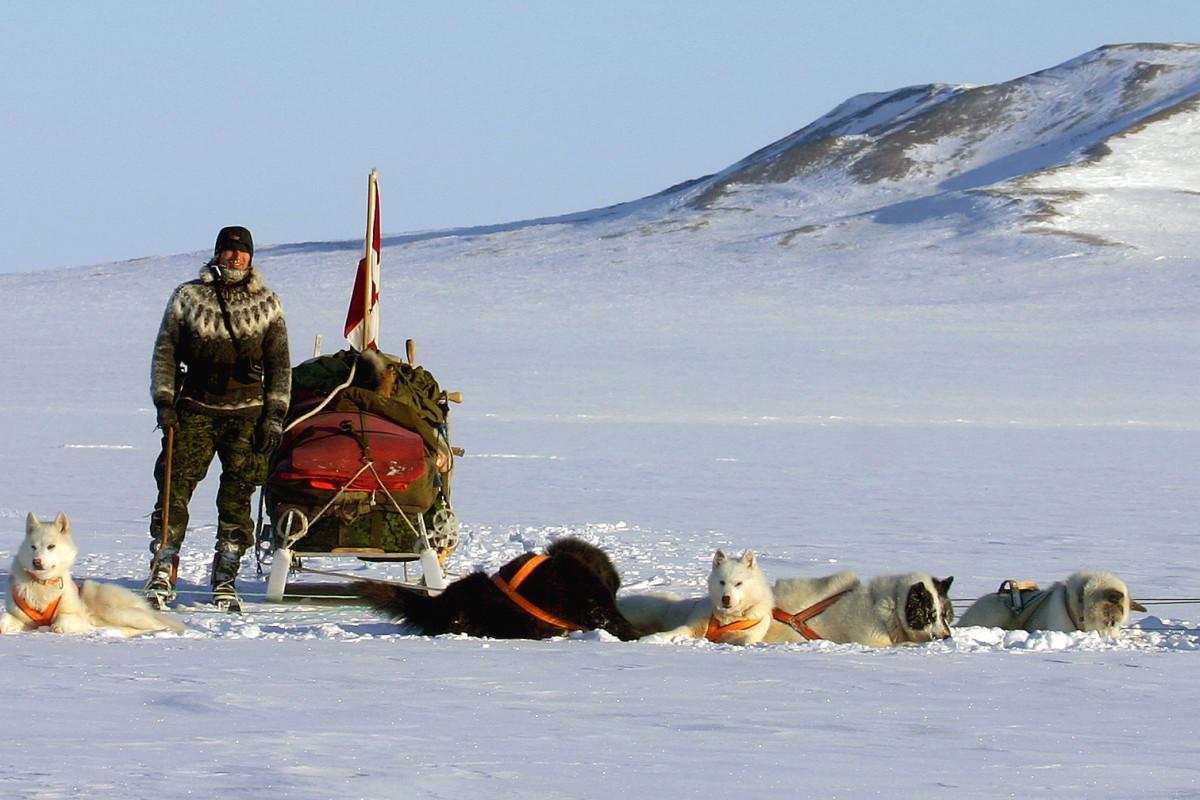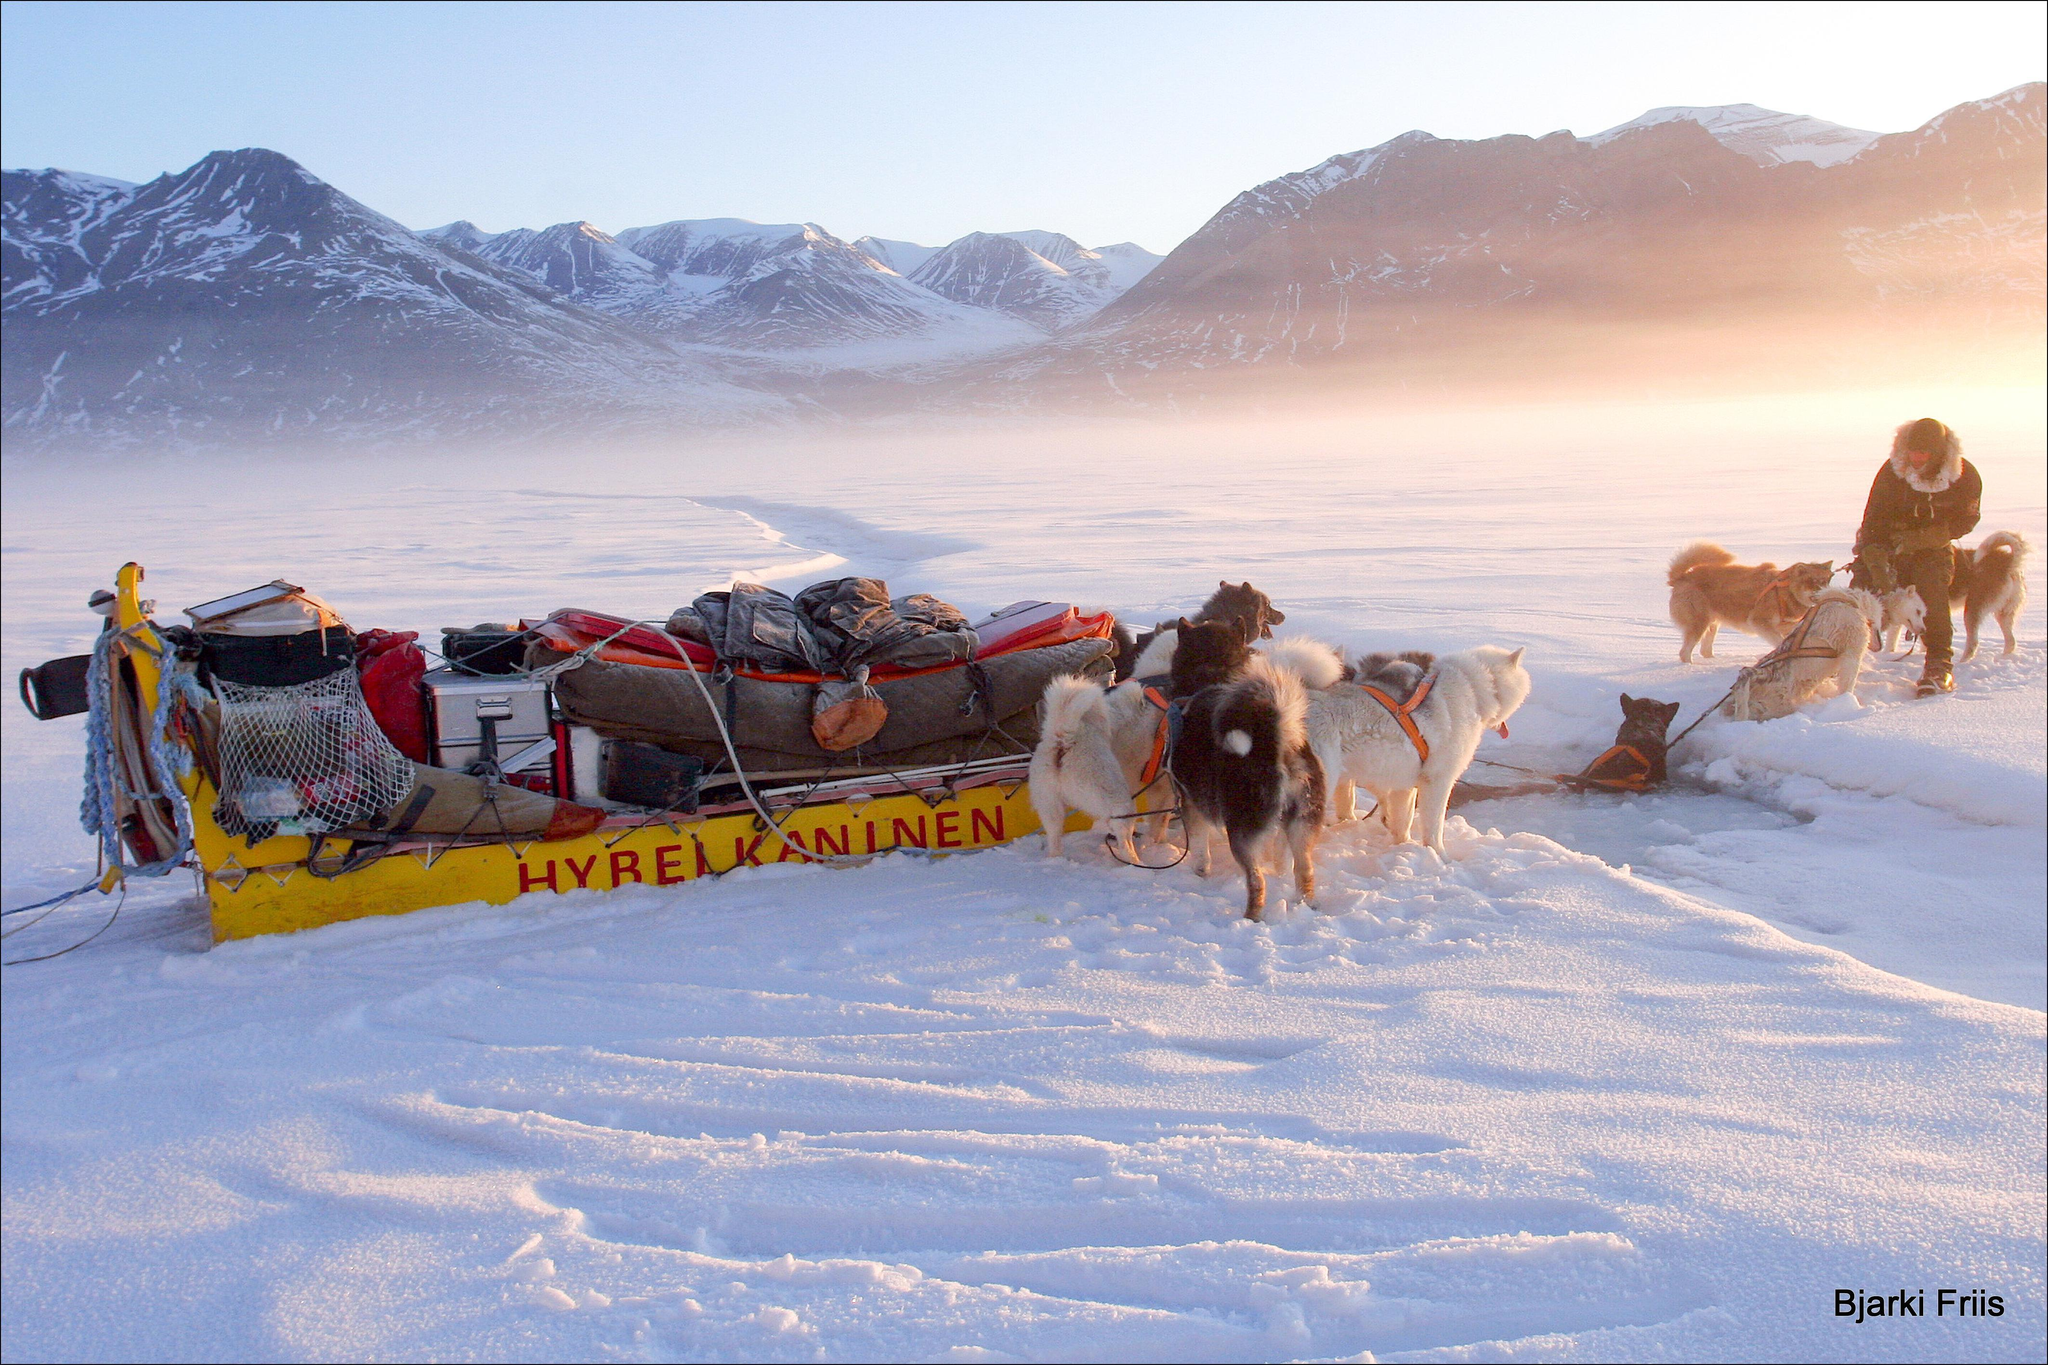The first image is the image on the left, the second image is the image on the right. Considering the images on both sides, is "There are sled dogs laying in the snow." valid? Answer yes or no. Yes. The first image is the image on the left, the second image is the image on the right. For the images shown, is this caption "Neither image shows a team of animals that are moving across the ground, and both images show sled dog teams." true? Answer yes or no. Yes. 